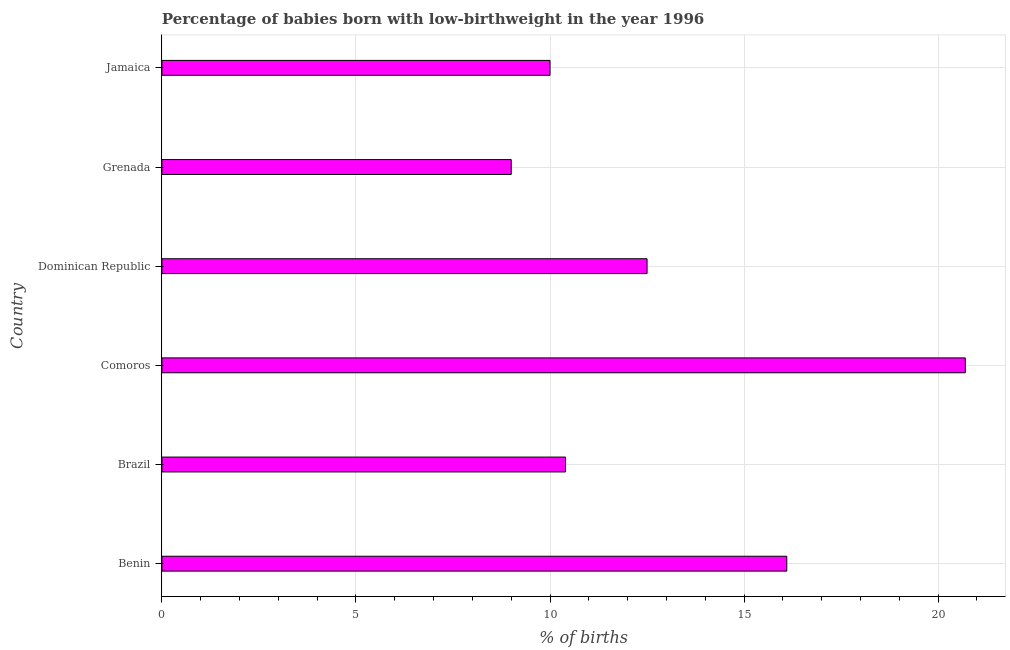Does the graph contain any zero values?
Keep it short and to the point. No. What is the title of the graph?
Ensure brevity in your answer.  Percentage of babies born with low-birthweight in the year 1996. What is the label or title of the X-axis?
Offer a very short reply. % of births. What is the label or title of the Y-axis?
Provide a short and direct response. Country. What is the percentage of babies who were born with low-birthweight in Comoros?
Provide a succinct answer. 20.7. Across all countries, what is the maximum percentage of babies who were born with low-birthweight?
Offer a very short reply. 20.7. Across all countries, what is the minimum percentage of babies who were born with low-birthweight?
Offer a terse response. 9. In which country was the percentage of babies who were born with low-birthweight maximum?
Keep it short and to the point. Comoros. In which country was the percentage of babies who were born with low-birthweight minimum?
Offer a very short reply. Grenada. What is the sum of the percentage of babies who were born with low-birthweight?
Give a very brief answer. 78.7. What is the difference between the percentage of babies who were born with low-birthweight in Brazil and Grenada?
Offer a terse response. 1.4. What is the average percentage of babies who were born with low-birthweight per country?
Ensure brevity in your answer.  13.12. What is the median percentage of babies who were born with low-birthweight?
Ensure brevity in your answer.  11.45. What is the ratio of the percentage of babies who were born with low-birthweight in Dominican Republic to that in Grenada?
Provide a succinct answer. 1.39. What is the difference between the highest and the lowest percentage of babies who were born with low-birthweight?
Offer a terse response. 11.7. In how many countries, is the percentage of babies who were born with low-birthweight greater than the average percentage of babies who were born with low-birthweight taken over all countries?
Provide a short and direct response. 2. How many bars are there?
Provide a succinct answer. 6. Are all the bars in the graph horizontal?
Your response must be concise. Yes. Are the values on the major ticks of X-axis written in scientific E-notation?
Your answer should be compact. No. What is the % of births of Benin?
Offer a very short reply. 16.1. What is the % of births in Brazil?
Your answer should be very brief. 10.4. What is the % of births in Comoros?
Your response must be concise. 20.7. What is the % of births in Dominican Republic?
Your answer should be compact. 12.5. What is the difference between the % of births in Benin and Comoros?
Your response must be concise. -4.6. What is the difference between the % of births in Benin and Dominican Republic?
Give a very brief answer. 3.6. What is the difference between the % of births in Brazil and Comoros?
Offer a terse response. -10.3. What is the difference between the % of births in Brazil and Jamaica?
Ensure brevity in your answer.  0.4. What is the difference between the % of births in Comoros and Dominican Republic?
Your answer should be compact. 8.2. What is the difference between the % of births in Dominican Republic and Jamaica?
Give a very brief answer. 2.5. What is the difference between the % of births in Grenada and Jamaica?
Keep it short and to the point. -1. What is the ratio of the % of births in Benin to that in Brazil?
Keep it short and to the point. 1.55. What is the ratio of the % of births in Benin to that in Comoros?
Offer a very short reply. 0.78. What is the ratio of the % of births in Benin to that in Dominican Republic?
Keep it short and to the point. 1.29. What is the ratio of the % of births in Benin to that in Grenada?
Your response must be concise. 1.79. What is the ratio of the % of births in Benin to that in Jamaica?
Your response must be concise. 1.61. What is the ratio of the % of births in Brazil to that in Comoros?
Your answer should be very brief. 0.5. What is the ratio of the % of births in Brazil to that in Dominican Republic?
Offer a terse response. 0.83. What is the ratio of the % of births in Brazil to that in Grenada?
Your answer should be very brief. 1.16. What is the ratio of the % of births in Brazil to that in Jamaica?
Ensure brevity in your answer.  1.04. What is the ratio of the % of births in Comoros to that in Dominican Republic?
Offer a terse response. 1.66. What is the ratio of the % of births in Comoros to that in Jamaica?
Offer a very short reply. 2.07. What is the ratio of the % of births in Dominican Republic to that in Grenada?
Make the answer very short. 1.39. 